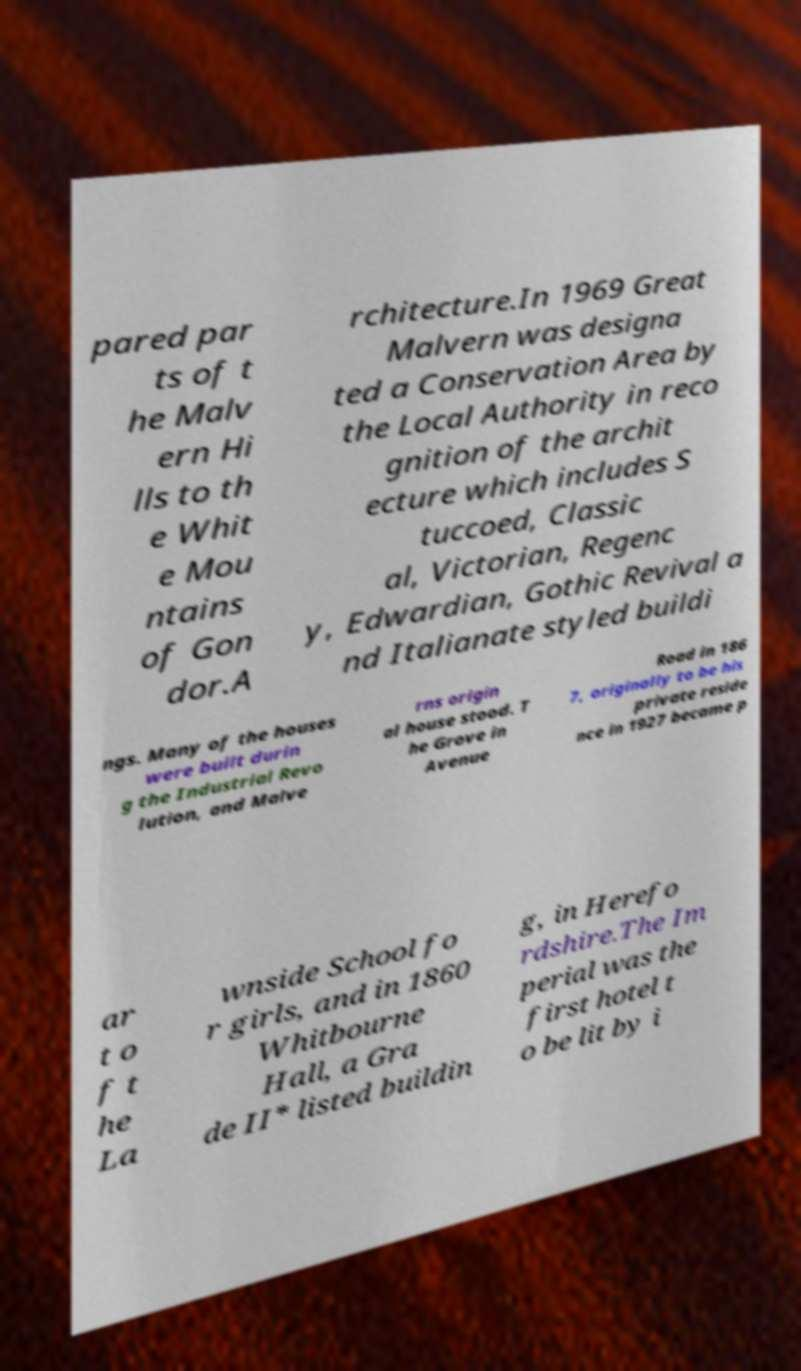Please identify and transcribe the text found in this image. pared par ts of t he Malv ern Hi lls to th e Whit e Mou ntains of Gon dor.A rchitecture.In 1969 Great Malvern was designa ted a Conservation Area by the Local Authority in reco gnition of the archit ecture which includes S tuccoed, Classic al, Victorian, Regenc y, Edwardian, Gothic Revival a nd Italianate styled buildi ngs. Many of the houses were built durin g the Industrial Revo lution, and Malve rns origin al house stood. T he Grove in Avenue Road in 186 7, originally to be his private reside nce in 1927 became p ar t o f t he La wnside School fo r girls, and in 1860 Whitbourne Hall, a Gra de II* listed buildin g, in Herefo rdshire.The Im perial was the first hotel t o be lit by i 